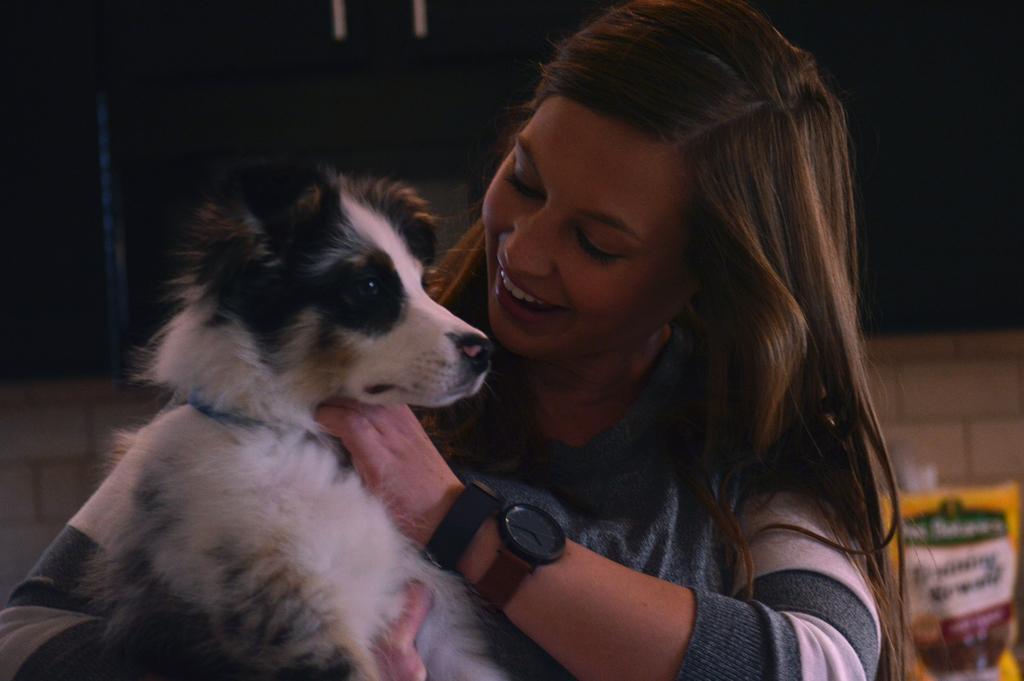Could you give a brief overview of what you see in this image? A woman is holding dog in her hands. 